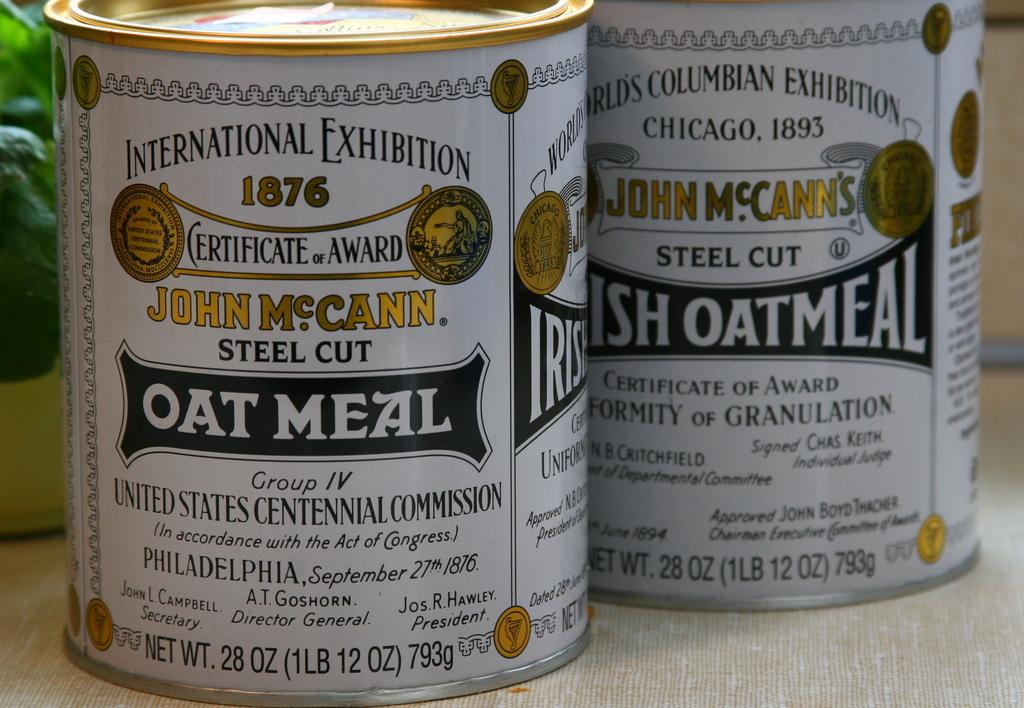<image>
Give a short and clear explanation of the subsequent image. Two cans of John McCann's steel cut oat meal sit on a counter. 